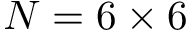<formula> <loc_0><loc_0><loc_500><loc_500>N = 6 \times 6</formula> 